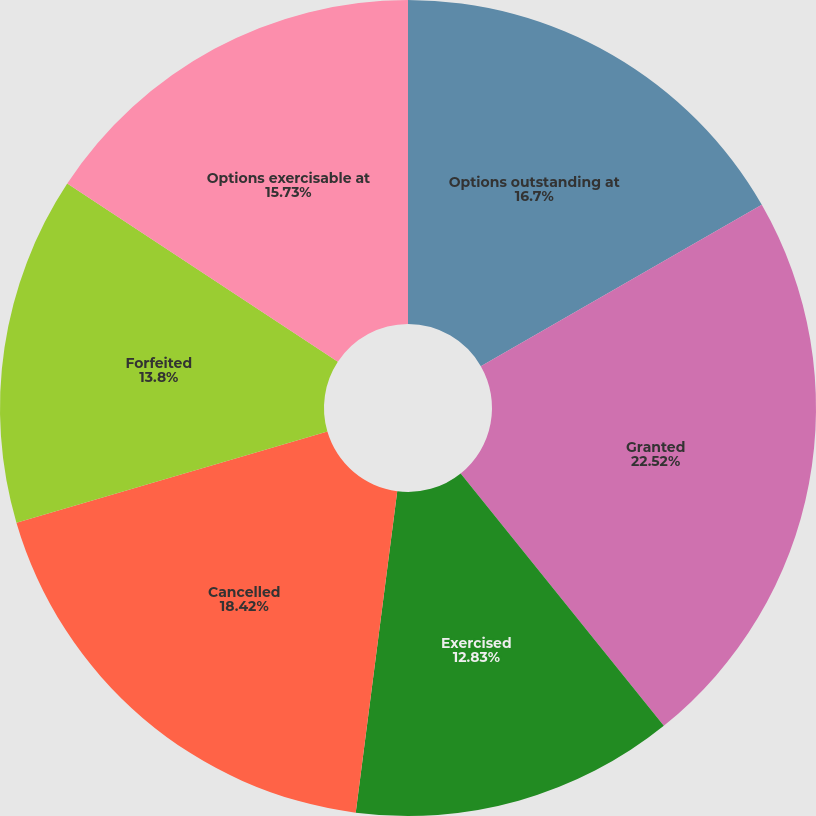Convert chart to OTSL. <chart><loc_0><loc_0><loc_500><loc_500><pie_chart><fcel>Options outstanding at<fcel>Granted<fcel>Exercised<fcel>Cancelled<fcel>Forfeited<fcel>Options exercisable at<nl><fcel>16.7%<fcel>22.51%<fcel>12.83%<fcel>18.42%<fcel>13.8%<fcel>15.73%<nl></chart> 